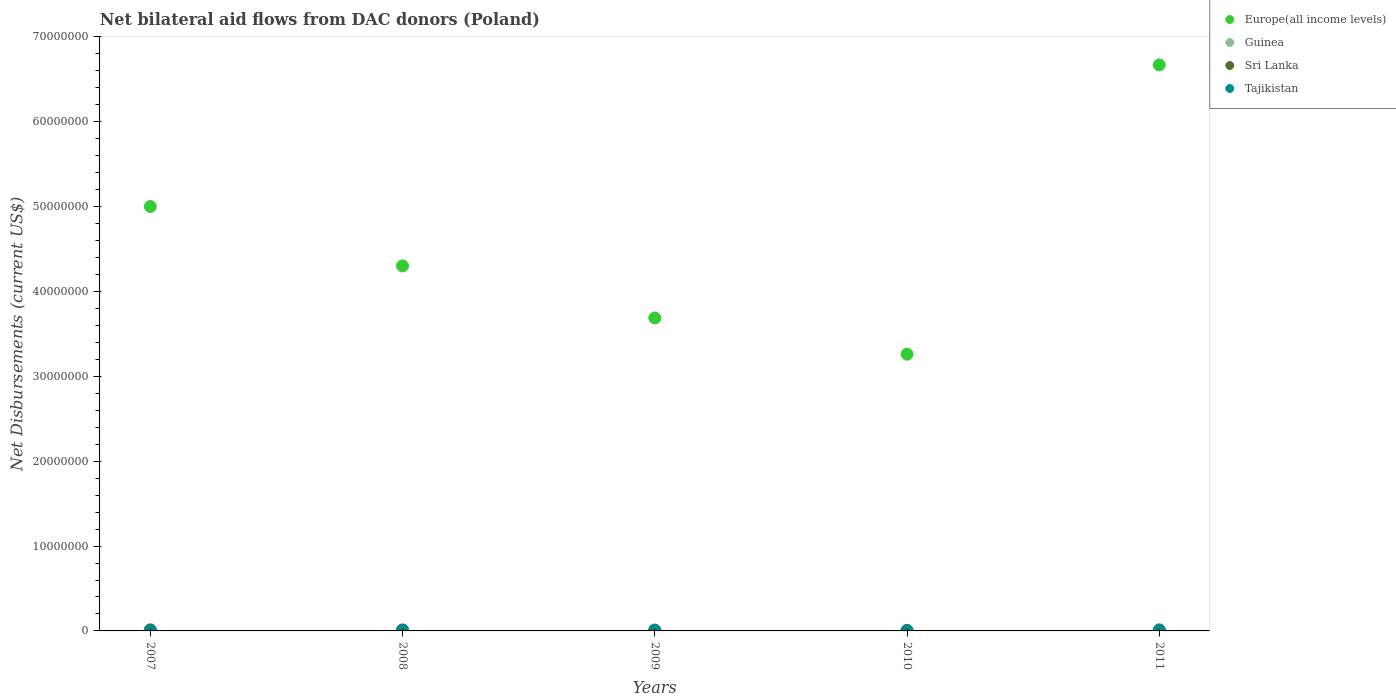Is the number of dotlines equal to the number of legend labels?
Keep it short and to the point. Yes. What is the net bilateral aid flows in Tajikistan in 2009?
Offer a very short reply. 7.00e+04. Across all years, what is the maximum net bilateral aid flows in Europe(all income levels)?
Make the answer very short. 6.67e+07. In which year was the net bilateral aid flows in Tajikistan minimum?
Your answer should be compact. 2010. What is the total net bilateral aid flows in Europe(all income levels) in the graph?
Offer a very short reply. 2.29e+08. What is the difference between the net bilateral aid flows in Sri Lanka in 2008 and that in 2009?
Give a very brief answer. -10000. What is the difference between the net bilateral aid flows in Sri Lanka in 2011 and the net bilateral aid flows in Europe(all income levels) in 2008?
Provide a succinct answer. -4.30e+07. What is the average net bilateral aid flows in Guinea per year?
Your answer should be compact. 1.80e+04. In the year 2009, what is the difference between the net bilateral aid flows in Tajikistan and net bilateral aid flows in Guinea?
Give a very brief answer. 6.00e+04. In how many years, is the net bilateral aid flows in Tajikistan greater than 28000000 US$?
Provide a succinct answer. 0. What is the ratio of the net bilateral aid flows in Guinea in 2010 to that in 2011?
Your answer should be very brief. 3. What is the difference between the highest and the second highest net bilateral aid flows in Europe(all income levels)?
Provide a succinct answer. 1.67e+07. In how many years, is the net bilateral aid flows in Tajikistan greater than the average net bilateral aid flows in Tajikistan taken over all years?
Your answer should be very brief. 2. Is it the case that in every year, the sum of the net bilateral aid flows in Guinea and net bilateral aid flows in Sri Lanka  is greater than the net bilateral aid flows in Tajikistan?
Make the answer very short. No. Does the net bilateral aid flows in Sri Lanka monotonically increase over the years?
Your answer should be very brief. No. Is the net bilateral aid flows in Tajikistan strictly greater than the net bilateral aid flows in Sri Lanka over the years?
Your answer should be compact. No. How many dotlines are there?
Provide a short and direct response. 4. How many years are there in the graph?
Your answer should be very brief. 5. Does the graph contain any zero values?
Offer a very short reply. No. Does the graph contain grids?
Provide a succinct answer. No. How are the legend labels stacked?
Your answer should be compact. Vertical. What is the title of the graph?
Ensure brevity in your answer.  Net bilateral aid flows from DAC donors (Poland). Does "Iraq" appear as one of the legend labels in the graph?
Offer a terse response. No. What is the label or title of the X-axis?
Ensure brevity in your answer.  Years. What is the label or title of the Y-axis?
Provide a succinct answer. Net Disbursements (current US$). What is the Net Disbursements (current US$) of Europe(all income levels) in 2007?
Keep it short and to the point. 5.00e+07. What is the Net Disbursements (current US$) in Sri Lanka in 2007?
Your answer should be compact. 1.30e+05. What is the Net Disbursements (current US$) of Tajikistan in 2007?
Provide a short and direct response. 5.00e+04. What is the Net Disbursements (current US$) in Europe(all income levels) in 2008?
Offer a very short reply. 4.30e+07. What is the Net Disbursements (current US$) in Tajikistan in 2008?
Provide a succinct answer. 1.10e+05. What is the Net Disbursements (current US$) of Europe(all income levels) in 2009?
Ensure brevity in your answer.  3.69e+07. What is the Net Disbursements (current US$) of Europe(all income levels) in 2010?
Provide a short and direct response. 3.26e+07. What is the Net Disbursements (current US$) in Europe(all income levels) in 2011?
Offer a terse response. 6.67e+07. What is the Net Disbursements (current US$) in Guinea in 2011?
Your response must be concise. 10000. Across all years, what is the maximum Net Disbursements (current US$) in Europe(all income levels)?
Offer a very short reply. 6.67e+07. Across all years, what is the maximum Net Disbursements (current US$) in Guinea?
Your answer should be compact. 3.00e+04. Across all years, what is the maximum Net Disbursements (current US$) of Tajikistan?
Give a very brief answer. 1.30e+05. Across all years, what is the minimum Net Disbursements (current US$) in Europe(all income levels)?
Your answer should be very brief. 3.26e+07. Across all years, what is the minimum Net Disbursements (current US$) in Tajikistan?
Give a very brief answer. 4.00e+04. What is the total Net Disbursements (current US$) of Europe(all income levels) in the graph?
Offer a terse response. 2.29e+08. What is the total Net Disbursements (current US$) of Guinea in the graph?
Give a very brief answer. 9.00e+04. What is the difference between the Net Disbursements (current US$) of Sri Lanka in 2007 and that in 2008?
Your response must be concise. 4.00e+04. What is the difference between the Net Disbursements (current US$) of Europe(all income levels) in 2007 and that in 2009?
Keep it short and to the point. 1.31e+07. What is the difference between the Net Disbursements (current US$) of Guinea in 2007 and that in 2009?
Offer a terse response. 10000. What is the difference between the Net Disbursements (current US$) of Sri Lanka in 2007 and that in 2009?
Provide a succinct answer. 3.00e+04. What is the difference between the Net Disbursements (current US$) in Tajikistan in 2007 and that in 2009?
Make the answer very short. -2.00e+04. What is the difference between the Net Disbursements (current US$) of Europe(all income levels) in 2007 and that in 2010?
Your answer should be compact. 1.74e+07. What is the difference between the Net Disbursements (current US$) in Guinea in 2007 and that in 2010?
Offer a terse response. -10000. What is the difference between the Net Disbursements (current US$) of Sri Lanka in 2007 and that in 2010?
Give a very brief answer. 9.00e+04. What is the difference between the Net Disbursements (current US$) in Europe(all income levels) in 2007 and that in 2011?
Give a very brief answer. -1.67e+07. What is the difference between the Net Disbursements (current US$) of Sri Lanka in 2007 and that in 2011?
Offer a very short reply. 1.20e+05. What is the difference between the Net Disbursements (current US$) of Europe(all income levels) in 2008 and that in 2009?
Provide a succinct answer. 6.13e+06. What is the difference between the Net Disbursements (current US$) in Sri Lanka in 2008 and that in 2009?
Give a very brief answer. -10000. What is the difference between the Net Disbursements (current US$) of Europe(all income levels) in 2008 and that in 2010?
Keep it short and to the point. 1.04e+07. What is the difference between the Net Disbursements (current US$) of Guinea in 2008 and that in 2010?
Keep it short and to the point. -10000. What is the difference between the Net Disbursements (current US$) of Tajikistan in 2008 and that in 2010?
Ensure brevity in your answer.  7.00e+04. What is the difference between the Net Disbursements (current US$) in Europe(all income levels) in 2008 and that in 2011?
Offer a terse response. -2.37e+07. What is the difference between the Net Disbursements (current US$) in Sri Lanka in 2008 and that in 2011?
Your response must be concise. 8.00e+04. What is the difference between the Net Disbursements (current US$) in Europe(all income levels) in 2009 and that in 2010?
Your answer should be very brief. 4.27e+06. What is the difference between the Net Disbursements (current US$) of Sri Lanka in 2009 and that in 2010?
Keep it short and to the point. 6.00e+04. What is the difference between the Net Disbursements (current US$) of Tajikistan in 2009 and that in 2010?
Give a very brief answer. 3.00e+04. What is the difference between the Net Disbursements (current US$) in Europe(all income levels) in 2009 and that in 2011?
Your response must be concise. -2.98e+07. What is the difference between the Net Disbursements (current US$) in Guinea in 2009 and that in 2011?
Give a very brief answer. 0. What is the difference between the Net Disbursements (current US$) of Sri Lanka in 2009 and that in 2011?
Give a very brief answer. 9.00e+04. What is the difference between the Net Disbursements (current US$) in Europe(all income levels) in 2010 and that in 2011?
Give a very brief answer. -3.41e+07. What is the difference between the Net Disbursements (current US$) of Guinea in 2010 and that in 2011?
Ensure brevity in your answer.  2.00e+04. What is the difference between the Net Disbursements (current US$) of Sri Lanka in 2010 and that in 2011?
Make the answer very short. 3.00e+04. What is the difference between the Net Disbursements (current US$) of Tajikistan in 2010 and that in 2011?
Your answer should be compact. -9.00e+04. What is the difference between the Net Disbursements (current US$) of Europe(all income levels) in 2007 and the Net Disbursements (current US$) of Guinea in 2008?
Ensure brevity in your answer.  5.00e+07. What is the difference between the Net Disbursements (current US$) of Europe(all income levels) in 2007 and the Net Disbursements (current US$) of Sri Lanka in 2008?
Make the answer very short. 4.99e+07. What is the difference between the Net Disbursements (current US$) of Europe(all income levels) in 2007 and the Net Disbursements (current US$) of Tajikistan in 2008?
Offer a terse response. 4.99e+07. What is the difference between the Net Disbursements (current US$) of Guinea in 2007 and the Net Disbursements (current US$) of Tajikistan in 2008?
Your answer should be compact. -9.00e+04. What is the difference between the Net Disbursements (current US$) of Europe(all income levels) in 2007 and the Net Disbursements (current US$) of Guinea in 2009?
Your answer should be compact. 5.00e+07. What is the difference between the Net Disbursements (current US$) in Europe(all income levels) in 2007 and the Net Disbursements (current US$) in Sri Lanka in 2009?
Offer a terse response. 4.99e+07. What is the difference between the Net Disbursements (current US$) in Europe(all income levels) in 2007 and the Net Disbursements (current US$) in Tajikistan in 2009?
Provide a succinct answer. 4.99e+07. What is the difference between the Net Disbursements (current US$) in Sri Lanka in 2007 and the Net Disbursements (current US$) in Tajikistan in 2009?
Offer a very short reply. 6.00e+04. What is the difference between the Net Disbursements (current US$) in Europe(all income levels) in 2007 and the Net Disbursements (current US$) in Guinea in 2010?
Provide a short and direct response. 5.00e+07. What is the difference between the Net Disbursements (current US$) of Europe(all income levels) in 2007 and the Net Disbursements (current US$) of Sri Lanka in 2010?
Make the answer very short. 5.00e+07. What is the difference between the Net Disbursements (current US$) in Europe(all income levels) in 2007 and the Net Disbursements (current US$) in Tajikistan in 2010?
Give a very brief answer. 5.00e+07. What is the difference between the Net Disbursements (current US$) in Guinea in 2007 and the Net Disbursements (current US$) in Tajikistan in 2010?
Your answer should be compact. -2.00e+04. What is the difference between the Net Disbursements (current US$) of Sri Lanka in 2007 and the Net Disbursements (current US$) of Tajikistan in 2010?
Ensure brevity in your answer.  9.00e+04. What is the difference between the Net Disbursements (current US$) of Europe(all income levels) in 2007 and the Net Disbursements (current US$) of Tajikistan in 2011?
Give a very brief answer. 4.99e+07. What is the difference between the Net Disbursements (current US$) in Guinea in 2007 and the Net Disbursements (current US$) in Tajikistan in 2011?
Make the answer very short. -1.10e+05. What is the difference between the Net Disbursements (current US$) of Sri Lanka in 2007 and the Net Disbursements (current US$) of Tajikistan in 2011?
Your answer should be compact. 0. What is the difference between the Net Disbursements (current US$) in Europe(all income levels) in 2008 and the Net Disbursements (current US$) in Guinea in 2009?
Provide a succinct answer. 4.30e+07. What is the difference between the Net Disbursements (current US$) in Europe(all income levels) in 2008 and the Net Disbursements (current US$) in Sri Lanka in 2009?
Offer a terse response. 4.29e+07. What is the difference between the Net Disbursements (current US$) in Europe(all income levels) in 2008 and the Net Disbursements (current US$) in Tajikistan in 2009?
Provide a short and direct response. 4.29e+07. What is the difference between the Net Disbursements (current US$) in Guinea in 2008 and the Net Disbursements (current US$) in Sri Lanka in 2009?
Your answer should be very brief. -8.00e+04. What is the difference between the Net Disbursements (current US$) in Europe(all income levels) in 2008 and the Net Disbursements (current US$) in Guinea in 2010?
Offer a very short reply. 4.30e+07. What is the difference between the Net Disbursements (current US$) of Europe(all income levels) in 2008 and the Net Disbursements (current US$) of Sri Lanka in 2010?
Ensure brevity in your answer.  4.30e+07. What is the difference between the Net Disbursements (current US$) of Europe(all income levels) in 2008 and the Net Disbursements (current US$) of Tajikistan in 2010?
Your response must be concise. 4.30e+07. What is the difference between the Net Disbursements (current US$) in Sri Lanka in 2008 and the Net Disbursements (current US$) in Tajikistan in 2010?
Offer a terse response. 5.00e+04. What is the difference between the Net Disbursements (current US$) in Europe(all income levels) in 2008 and the Net Disbursements (current US$) in Guinea in 2011?
Your response must be concise. 4.30e+07. What is the difference between the Net Disbursements (current US$) in Europe(all income levels) in 2008 and the Net Disbursements (current US$) in Sri Lanka in 2011?
Your answer should be very brief. 4.30e+07. What is the difference between the Net Disbursements (current US$) in Europe(all income levels) in 2008 and the Net Disbursements (current US$) in Tajikistan in 2011?
Provide a short and direct response. 4.29e+07. What is the difference between the Net Disbursements (current US$) of Guinea in 2008 and the Net Disbursements (current US$) of Sri Lanka in 2011?
Give a very brief answer. 10000. What is the difference between the Net Disbursements (current US$) of Sri Lanka in 2008 and the Net Disbursements (current US$) of Tajikistan in 2011?
Your answer should be compact. -4.00e+04. What is the difference between the Net Disbursements (current US$) of Europe(all income levels) in 2009 and the Net Disbursements (current US$) of Guinea in 2010?
Ensure brevity in your answer.  3.68e+07. What is the difference between the Net Disbursements (current US$) in Europe(all income levels) in 2009 and the Net Disbursements (current US$) in Sri Lanka in 2010?
Your response must be concise. 3.68e+07. What is the difference between the Net Disbursements (current US$) of Europe(all income levels) in 2009 and the Net Disbursements (current US$) of Tajikistan in 2010?
Provide a succinct answer. 3.68e+07. What is the difference between the Net Disbursements (current US$) of Guinea in 2009 and the Net Disbursements (current US$) of Tajikistan in 2010?
Offer a very short reply. -3.00e+04. What is the difference between the Net Disbursements (current US$) in Sri Lanka in 2009 and the Net Disbursements (current US$) in Tajikistan in 2010?
Your answer should be very brief. 6.00e+04. What is the difference between the Net Disbursements (current US$) of Europe(all income levels) in 2009 and the Net Disbursements (current US$) of Guinea in 2011?
Make the answer very short. 3.69e+07. What is the difference between the Net Disbursements (current US$) in Europe(all income levels) in 2009 and the Net Disbursements (current US$) in Sri Lanka in 2011?
Your answer should be very brief. 3.69e+07. What is the difference between the Net Disbursements (current US$) in Europe(all income levels) in 2009 and the Net Disbursements (current US$) in Tajikistan in 2011?
Provide a succinct answer. 3.68e+07. What is the difference between the Net Disbursements (current US$) in Europe(all income levels) in 2010 and the Net Disbursements (current US$) in Guinea in 2011?
Offer a terse response. 3.26e+07. What is the difference between the Net Disbursements (current US$) of Europe(all income levels) in 2010 and the Net Disbursements (current US$) of Sri Lanka in 2011?
Your response must be concise. 3.26e+07. What is the difference between the Net Disbursements (current US$) in Europe(all income levels) in 2010 and the Net Disbursements (current US$) in Tajikistan in 2011?
Provide a short and direct response. 3.25e+07. What is the difference between the Net Disbursements (current US$) of Guinea in 2010 and the Net Disbursements (current US$) of Sri Lanka in 2011?
Your answer should be compact. 2.00e+04. What is the average Net Disbursements (current US$) in Europe(all income levels) per year?
Offer a very short reply. 4.58e+07. What is the average Net Disbursements (current US$) of Guinea per year?
Your answer should be very brief. 1.80e+04. What is the average Net Disbursements (current US$) in Sri Lanka per year?
Ensure brevity in your answer.  7.40e+04. In the year 2007, what is the difference between the Net Disbursements (current US$) of Europe(all income levels) and Net Disbursements (current US$) of Guinea?
Your answer should be compact. 5.00e+07. In the year 2007, what is the difference between the Net Disbursements (current US$) of Europe(all income levels) and Net Disbursements (current US$) of Sri Lanka?
Offer a very short reply. 4.99e+07. In the year 2007, what is the difference between the Net Disbursements (current US$) in Europe(all income levels) and Net Disbursements (current US$) in Tajikistan?
Your answer should be very brief. 5.00e+07. In the year 2008, what is the difference between the Net Disbursements (current US$) in Europe(all income levels) and Net Disbursements (current US$) in Guinea?
Give a very brief answer. 4.30e+07. In the year 2008, what is the difference between the Net Disbursements (current US$) of Europe(all income levels) and Net Disbursements (current US$) of Sri Lanka?
Provide a succinct answer. 4.29e+07. In the year 2008, what is the difference between the Net Disbursements (current US$) of Europe(all income levels) and Net Disbursements (current US$) of Tajikistan?
Your answer should be very brief. 4.29e+07. In the year 2008, what is the difference between the Net Disbursements (current US$) in Guinea and Net Disbursements (current US$) in Sri Lanka?
Your answer should be compact. -7.00e+04. In the year 2008, what is the difference between the Net Disbursements (current US$) in Guinea and Net Disbursements (current US$) in Tajikistan?
Your response must be concise. -9.00e+04. In the year 2008, what is the difference between the Net Disbursements (current US$) in Sri Lanka and Net Disbursements (current US$) in Tajikistan?
Give a very brief answer. -2.00e+04. In the year 2009, what is the difference between the Net Disbursements (current US$) in Europe(all income levels) and Net Disbursements (current US$) in Guinea?
Give a very brief answer. 3.69e+07. In the year 2009, what is the difference between the Net Disbursements (current US$) in Europe(all income levels) and Net Disbursements (current US$) in Sri Lanka?
Your answer should be very brief. 3.68e+07. In the year 2009, what is the difference between the Net Disbursements (current US$) in Europe(all income levels) and Net Disbursements (current US$) in Tajikistan?
Give a very brief answer. 3.68e+07. In the year 2009, what is the difference between the Net Disbursements (current US$) of Guinea and Net Disbursements (current US$) of Sri Lanka?
Your answer should be compact. -9.00e+04. In the year 2010, what is the difference between the Net Disbursements (current US$) of Europe(all income levels) and Net Disbursements (current US$) of Guinea?
Ensure brevity in your answer.  3.26e+07. In the year 2010, what is the difference between the Net Disbursements (current US$) of Europe(all income levels) and Net Disbursements (current US$) of Sri Lanka?
Provide a short and direct response. 3.26e+07. In the year 2010, what is the difference between the Net Disbursements (current US$) in Europe(all income levels) and Net Disbursements (current US$) in Tajikistan?
Offer a terse response. 3.26e+07. In the year 2011, what is the difference between the Net Disbursements (current US$) of Europe(all income levels) and Net Disbursements (current US$) of Guinea?
Make the answer very short. 6.67e+07. In the year 2011, what is the difference between the Net Disbursements (current US$) in Europe(all income levels) and Net Disbursements (current US$) in Sri Lanka?
Your response must be concise. 6.67e+07. In the year 2011, what is the difference between the Net Disbursements (current US$) of Europe(all income levels) and Net Disbursements (current US$) of Tajikistan?
Your response must be concise. 6.66e+07. What is the ratio of the Net Disbursements (current US$) of Europe(all income levels) in 2007 to that in 2008?
Ensure brevity in your answer.  1.16. What is the ratio of the Net Disbursements (current US$) in Guinea in 2007 to that in 2008?
Provide a succinct answer. 1. What is the ratio of the Net Disbursements (current US$) in Sri Lanka in 2007 to that in 2008?
Make the answer very short. 1.44. What is the ratio of the Net Disbursements (current US$) in Tajikistan in 2007 to that in 2008?
Give a very brief answer. 0.45. What is the ratio of the Net Disbursements (current US$) in Europe(all income levels) in 2007 to that in 2009?
Give a very brief answer. 1.36. What is the ratio of the Net Disbursements (current US$) of Europe(all income levels) in 2007 to that in 2010?
Offer a terse response. 1.53. What is the ratio of the Net Disbursements (current US$) in Guinea in 2007 to that in 2010?
Offer a very short reply. 0.67. What is the ratio of the Net Disbursements (current US$) of Sri Lanka in 2007 to that in 2010?
Keep it short and to the point. 3.25. What is the ratio of the Net Disbursements (current US$) of Tajikistan in 2007 to that in 2010?
Give a very brief answer. 1.25. What is the ratio of the Net Disbursements (current US$) of Europe(all income levels) in 2007 to that in 2011?
Provide a succinct answer. 0.75. What is the ratio of the Net Disbursements (current US$) of Guinea in 2007 to that in 2011?
Keep it short and to the point. 2. What is the ratio of the Net Disbursements (current US$) in Tajikistan in 2007 to that in 2011?
Ensure brevity in your answer.  0.38. What is the ratio of the Net Disbursements (current US$) of Europe(all income levels) in 2008 to that in 2009?
Ensure brevity in your answer.  1.17. What is the ratio of the Net Disbursements (current US$) of Sri Lanka in 2008 to that in 2009?
Make the answer very short. 0.9. What is the ratio of the Net Disbursements (current US$) in Tajikistan in 2008 to that in 2009?
Ensure brevity in your answer.  1.57. What is the ratio of the Net Disbursements (current US$) in Europe(all income levels) in 2008 to that in 2010?
Ensure brevity in your answer.  1.32. What is the ratio of the Net Disbursements (current US$) in Guinea in 2008 to that in 2010?
Give a very brief answer. 0.67. What is the ratio of the Net Disbursements (current US$) of Sri Lanka in 2008 to that in 2010?
Give a very brief answer. 2.25. What is the ratio of the Net Disbursements (current US$) in Tajikistan in 2008 to that in 2010?
Your answer should be very brief. 2.75. What is the ratio of the Net Disbursements (current US$) in Europe(all income levels) in 2008 to that in 2011?
Your answer should be very brief. 0.64. What is the ratio of the Net Disbursements (current US$) in Sri Lanka in 2008 to that in 2011?
Offer a terse response. 9. What is the ratio of the Net Disbursements (current US$) in Tajikistan in 2008 to that in 2011?
Your response must be concise. 0.85. What is the ratio of the Net Disbursements (current US$) of Europe(all income levels) in 2009 to that in 2010?
Give a very brief answer. 1.13. What is the ratio of the Net Disbursements (current US$) of Guinea in 2009 to that in 2010?
Provide a succinct answer. 0.33. What is the ratio of the Net Disbursements (current US$) in Tajikistan in 2009 to that in 2010?
Offer a terse response. 1.75. What is the ratio of the Net Disbursements (current US$) of Europe(all income levels) in 2009 to that in 2011?
Your response must be concise. 0.55. What is the ratio of the Net Disbursements (current US$) in Sri Lanka in 2009 to that in 2011?
Your answer should be compact. 10. What is the ratio of the Net Disbursements (current US$) in Tajikistan in 2009 to that in 2011?
Your answer should be compact. 0.54. What is the ratio of the Net Disbursements (current US$) in Europe(all income levels) in 2010 to that in 2011?
Your answer should be very brief. 0.49. What is the ratio of the Net Disbursements (current US$) of Tajikistan in 2010 to that in 2011?
Offer a very short reply. 0.31. What is the difference between the highest and the second highest Net Disbursements (current US$) in Europe(all income levels)?
Ensure brevity in your answer.  1.67e+07. What is the difference between the highest and the second highest Net Disbursements (current US$) in Tajikistan?
Provide a succinct answer. 2.00e+04. What is the difference between the highest and the lowest Net Disbursements (current US$) of Europe(all income levels)?
Provide a short and direct response. 3.41e+07. 